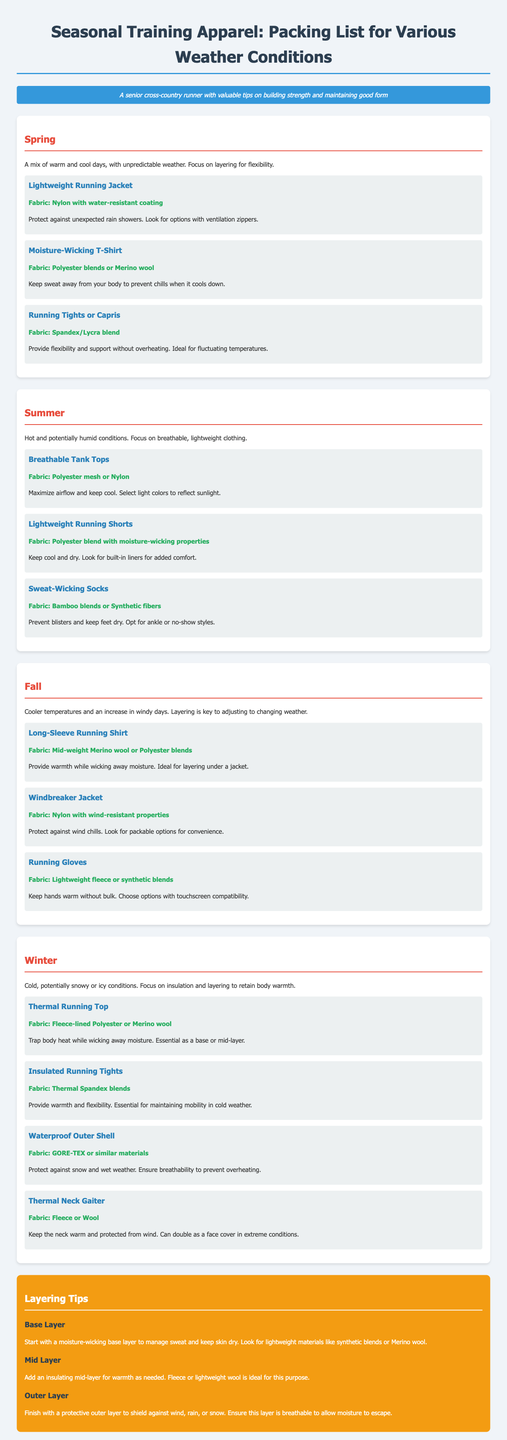What is the fabric of the Lightweight Running Jacket? The fabric details for the Lightweight Running Jacket are mentioned in the Spring section, stating it is made from nylon with a water-resistant coating.
Answer: Nylon with water-resistant coating How many types of socks are mentioned for summer training? The document lists sweat-wicking socks in the Summer section as important apparel, so we count it as one type mentioned specifically for summer.
Answer: One type What is the primary focus of Fall training apparel? The Fall section specifies that layering is key to adjusting to changing weather, highlighting the importance of flexibility.
Answer: Layering Which season suggests using Merino wool for a running shirt? The Fall section states that a Long-Sleeve Running Shirt made from mid-weight Merino wool or polyester blends is recommended.
Answer: Fall What are the key elements of a base layer according to the layering tips? The layering tips state that a base layer should be moisture-wicking to manage sweat and keep skin dry, describing the ideal materials in the document.
Answer: Moisture-wicking What type of outer layer is recommended for winter? The document suggests a waterproof outer shell made from GORE-TEX or similar materials in the Winter section as a protective outer layer.
Answer: Waterproof outer shell What fabric is suggested for thermal neck gaiters? The Winter section mentions that thermal neck gaiters should be made from fleece or wool.
Answer: Fleece or wool What is an ideal fabric for mid-layers? The layering tips indicate that fleece or lightweight wool is ideal for mid-layers to add warmth as needed.
Answer: Fleece or lightweight wool 